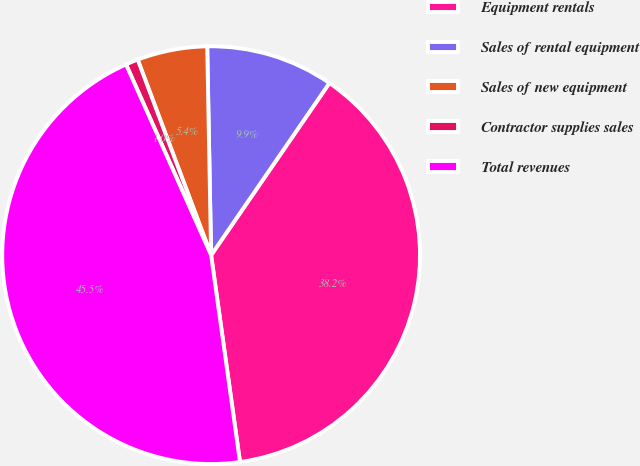Convert chart to OTSL. <chart><loc_0><loc_0><loc_500><loc_500><pie_chart><fcel>Equipment rentals<fcel>Sales of rental equipment<fcel>Sales of new equipment<fcel>Contractor supplies sales<fcel>Total revenues<nl><fcel>38.21%<fcel>9.88%<fcel>5.42%<fcel>0.96%<fcel>45.53%<nl></chart> 